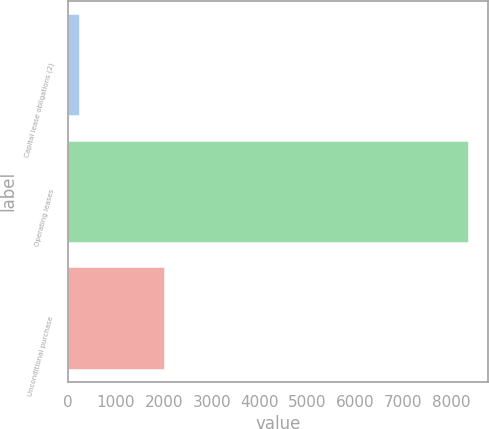<chart> <loc_0><loc_0><loc_500><loc_500><bar_chart><fcel>Capital lease obligations (2)<fcel>Operating leases<fcel>Unconditional purchase<nl><fcel>238<fcel>8342<fcel>1993<nl></chart> 